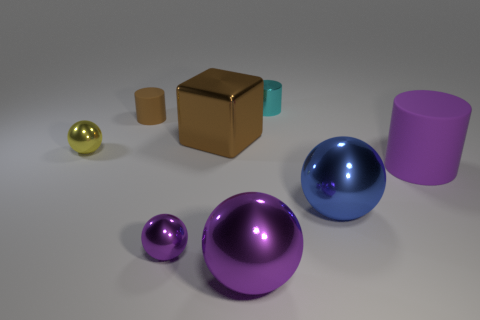Subtract all gray cylinders. Subtract all green blocks. How many cylinders are left? 3 Add 2 yellow shiny things. How many objects exist? 10 Subtract all cylinders. How many objects are left? 5 Subtract all big brown metallic objects. Subtract all big red objects. How many objects are left? 7 Add 8 blue metallic things. How many blue metallic things are left? 9 Add 1 big red matte cylinders. How many big red matte cylinders exist? 1 Subtract 1 purple cylinders. How many objects are left? 7 